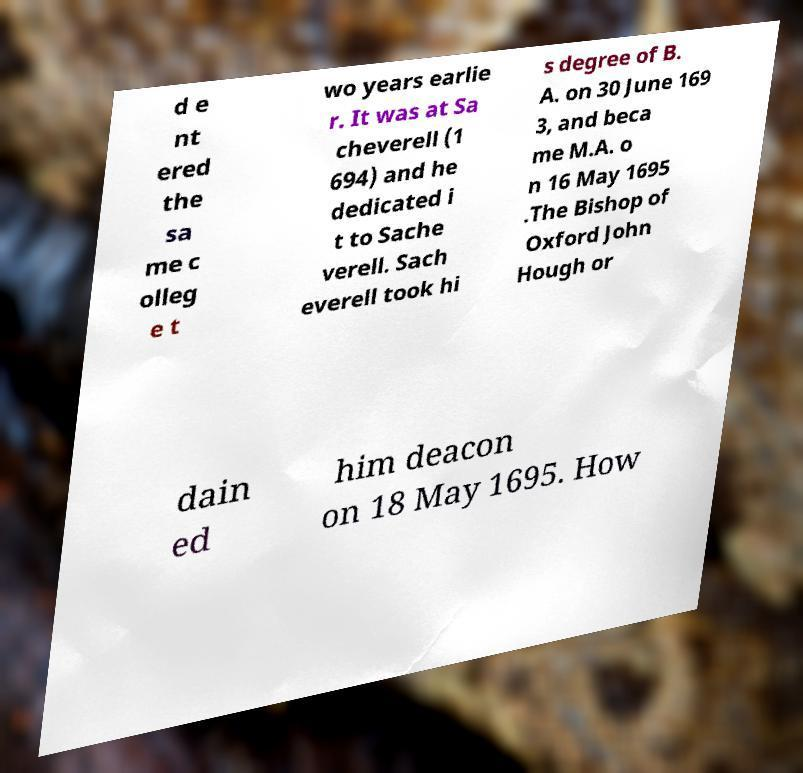Can you accurately transcribe the text from the provided image for me? d e nt ered the sa me c olleg e t wo years earlie r. It was at Sa cheverell (1 694) and he dedicated i t to Sache verell. Sach everell took hi s degree of B. A. on 30 June 169 3, and beca me M.A. o n 16 May 1695 .The Bishop of Oxford John Hough or dain ed him deacon on 18 May 1695. How 